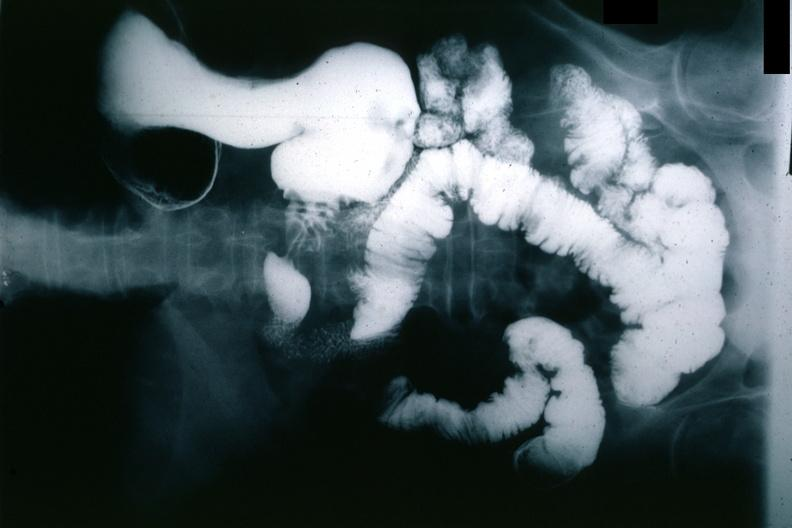s corpus luteum present?
Answer the question using a single word or phrase. No 